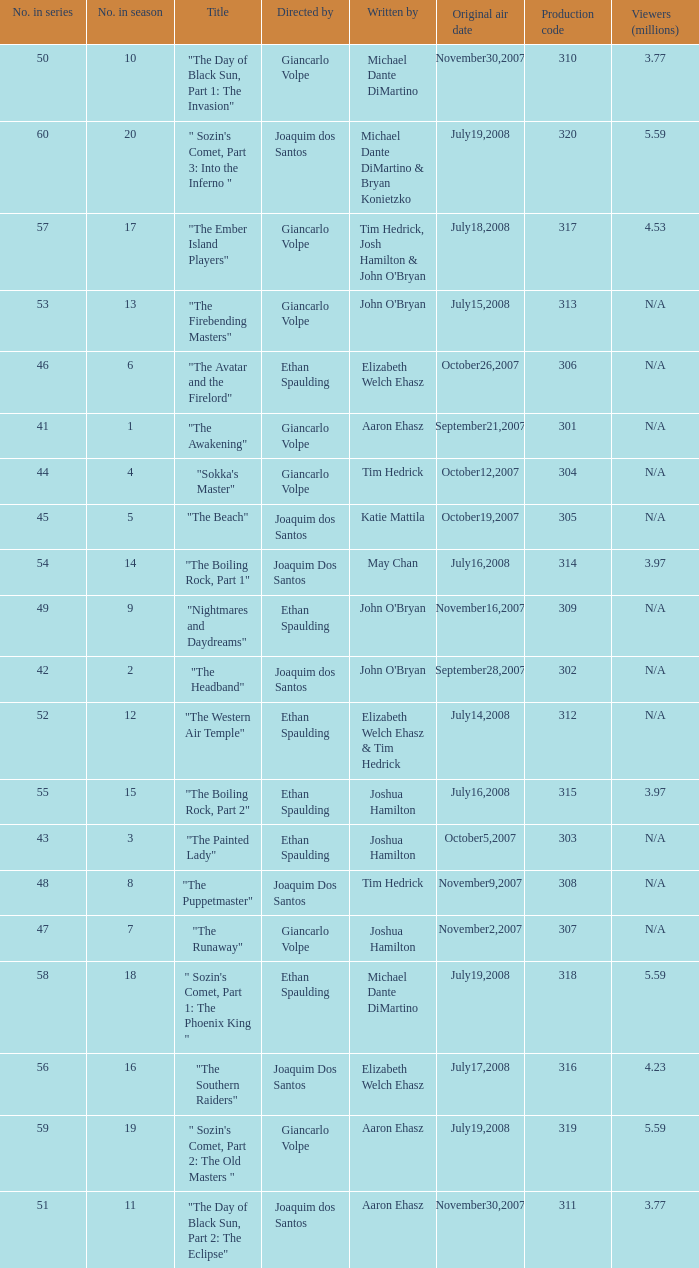What season has an episode written by john o'bryan and directed by ethan spaulding? 9.0. 